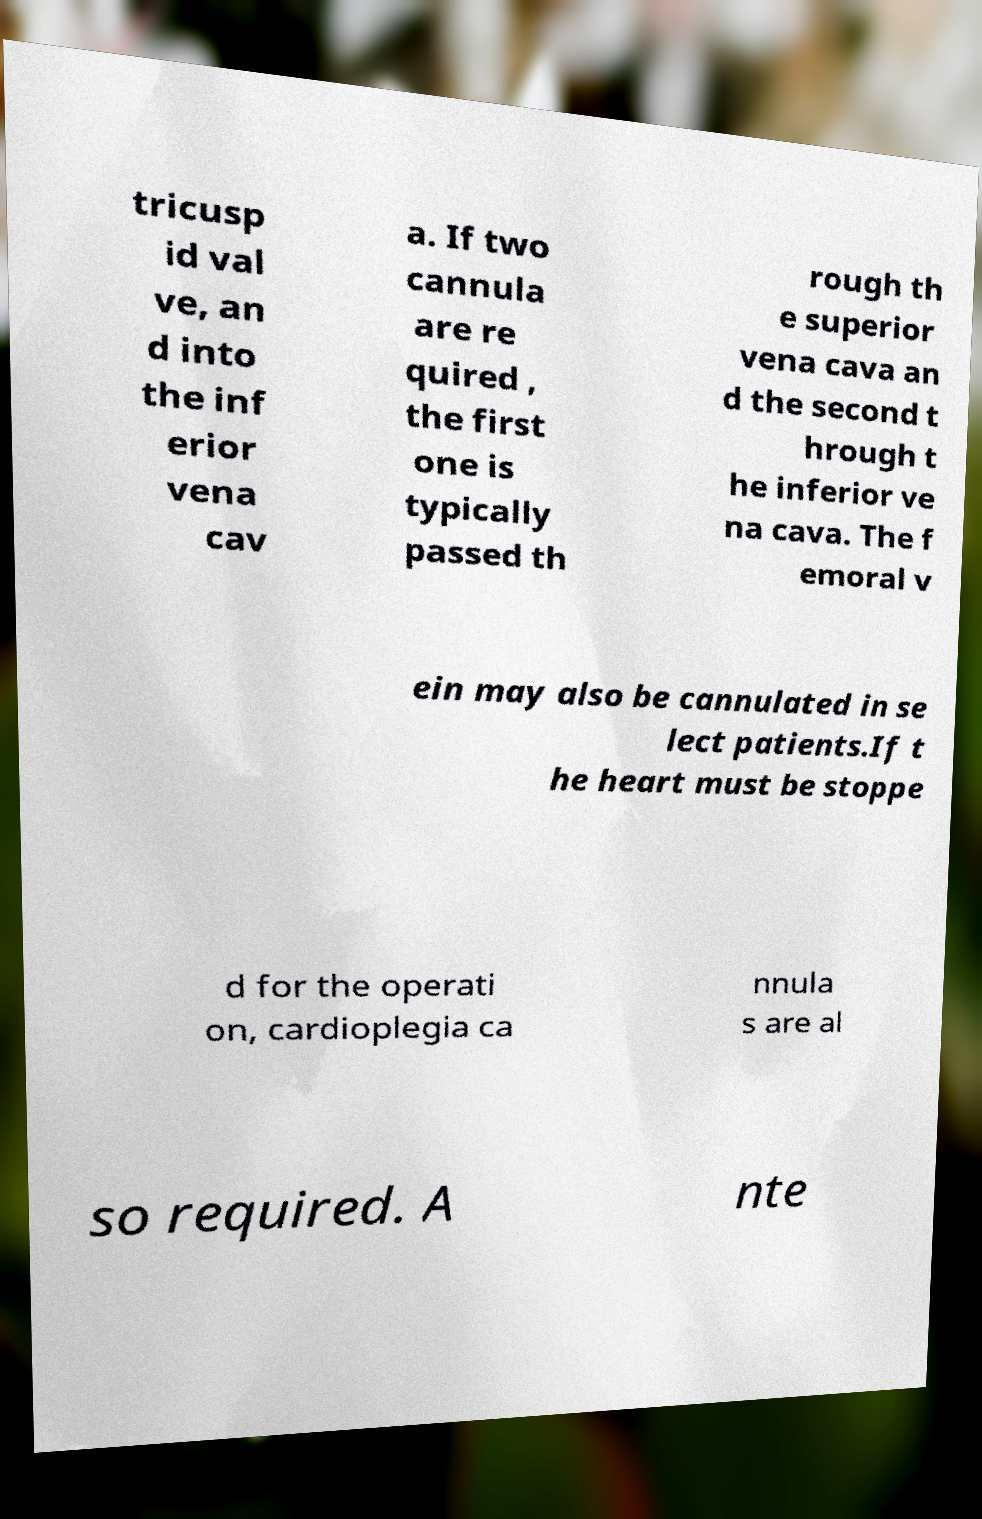There's text embedded in this image that I need extracted. Can you transcribe it verbatim? tricusp id val ve, an d into the inf erior vena cav a. If two cannula are re quired , the first one is typically passed th rough th e superior vena cava an d the second t hrough t he inferior ve na cava. The f emoral v ein may also be cannulated in se lect patients.If t he heart must be stoppe d for the operati on, cardioplegia ca nnula s are al so required. A nte 